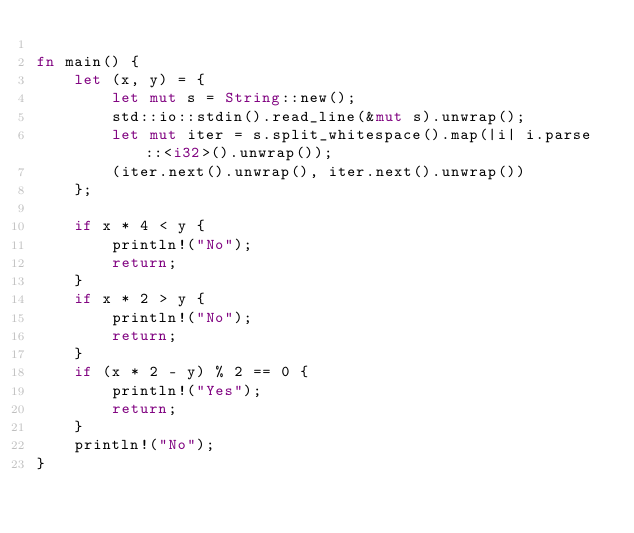<code> <loc_0><loc_0><loc_500><loc_500><_Rust_>
fn main() {
    let (x, y) = {
        let mut s = String::new();
        std::io::stdin().read_line(&mut s).unwrap();
        let mut iter = s.split_whitespace().map(|i| i.parse::<i32>().unwrap());
        (iter.next().unwrap(), iter.next().unwrap())
    };

    if x * 4 < y {
        println!("No");
        return;
    }
    if x * 2 > y {
        println!("No");
        return;
    }
    if (x * 2 - y) % 2 == 0 {
        println!("Yes");
        return;
    }
    println!("No");
}</code> 